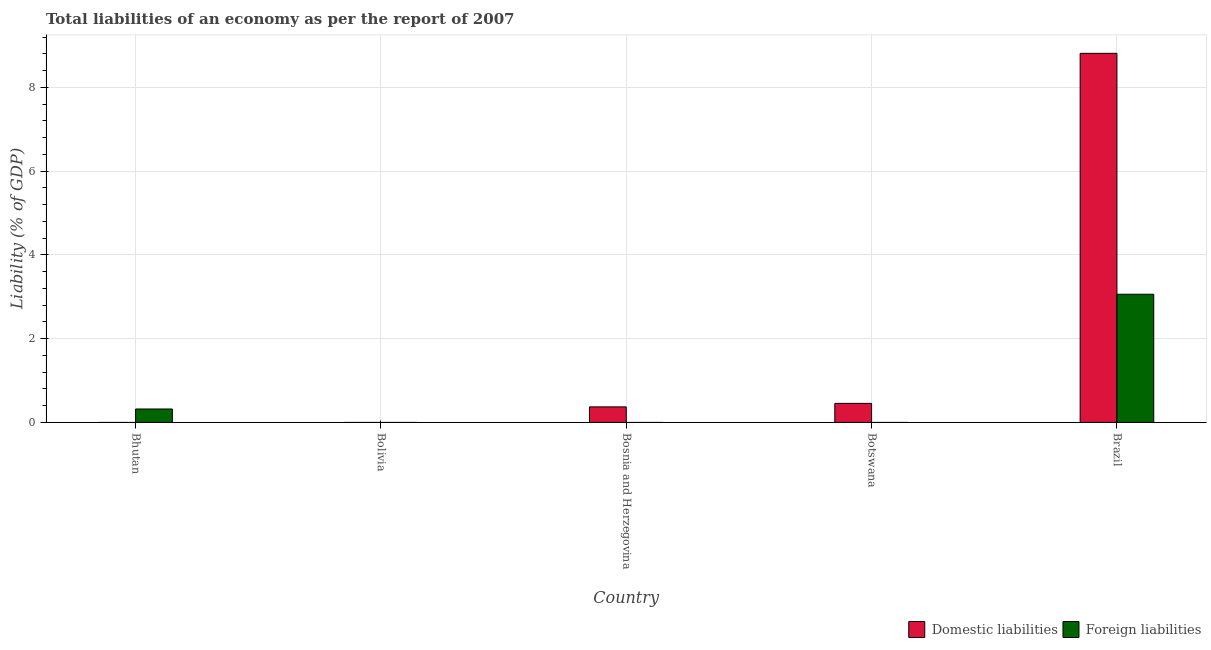Are the number of bars per tick equal to the number of legend labels?
Offer a very short reply. No. How many bars are there on the 3rd tick from the right?
Your response must be concise. 1. What is the label of the 4th group of bars from the left?
Offer a very short reply. Botswana. In how many cases, is the number of bars for a given country not equal to the number of legend labels?
Keep it short and to the point. 4. What is the incurrence of foreign liabilities in Bhutan?
Offer a terse response. 0.32. Across all countries, what is the maximum incurrence of foreign liabilities?
Provide a succinct answer. 3.06. Across all countries, what is the minimum incurrence of foreign liabilities?
Your response must be concise. 0. What is the total incurrence of foreign liabilities in the graph?
Provide a short and direct response. 3.38. What is the difference between the incurrence of domestic liabilities in Botswana and that in Brazil?
Offer a terse response. -8.36. What is the difference between the incurrence of foreign liabilities in Brazil and the incurrence of domestic liabilities in Bhutan?
Provide a short and direct response. 3.06. What is the average incurrence of domestic liabilities per country?
Give a very brief answer. 1.93. What is the difference between the incurrence of domestic liabilities and incurrence of foreign liabilities in Brazil?
Make the answer very short. 5.75. What is the ratio of the incurrence of domestic liabilities in Bosnia and Herzegovina to that in Botswana?
Keep it short and to the point. 0.82. Is the incurrence of domestic liabilities in Botswana less than that in Brazil?
Your response must be concise. Yes. What is the difference between the highest and the second highest incurrence of domestic liabilities?
Make the answer very short. 8.36. What is the difference between the highest and the lowest incurrence of domestic liabilities?
Provide a succinct answer. 8.81. How many bars are there?
Make the answer very short. 5. Are all the bars in the graph horizontal?
Keep it short and to the point. No. What is the difference between two consecutive major ticks on the Y-axis?
Offer a terse response. 2. Are the values on the major ticks of Y-axis written in scientific E-notation?
Make the answer very short. No. Does the graph contain any zero values?
Make the answer very short. Yes. Where does the legend appear in the graph?
Make the answer very short. Bottom right. How are the legend labels stacked?
Make the answer very short. Horizontal. What is the title of the graph?
Your answer should be very brief. Total liabilities of an economy as per the report of 2007. What is the label or title of the Y-axis?
Keep it short and to the point. Liability (% of GDP). What is the Liability (% of GDP) of Domestic liabilities in Bhutan?
Offer a very short reply. 0. What is the Liability (% of GDP) in Foreign liabilities in Bhutan?
Offer a very short reply. 0.32. What is the Liability (% of GDP) in Domestic liabilities in Bolivia?
Keep it short and to the point. 0. What is the Liability (% of GDP) of Foreign liabilities in Bolivia?
Your answer should be very brief. 0. What is the Liability (% of GDP) in Domestic liabilities in Bosnia and Herzegovina?
Give a very brief answer. 0.37. What is the Liability (% of GDP) in Domestic liabilities in Botswana?
Your answer should be very brief. 0.45. What is the Liability (% of GDP) in Foreign liabilities in Botswana?
Offer a very short reply. 0. What is the Liability (% of GDP) in Domestic liabilities in Brazil?
Provide a succinct answer. 8.81. What is the Liability (% of GDP) of Foreign liabilities in Brazil?
Your response must be concise. 3.06. Across all countries, what is the maximum Liability (% of GDP) in Domestic liabilities?
Keep it short and to the point. 8.81. Across all countries, what is the maximum Liability (% of GDP) of Foreign liabilities?
Keep it short and to the point. 3.06. Across all countries, what is the minimum Liability (% of GDP) of Domestic liabilities?
Offer a very short reply. 0. What is the total Liability (% of GDP) in Domestic liabilities in the graph?
Ensure brevity in your answer.  9.64. What is the total Liability (% of GDP) of Foreign liabilities in the graph?
Your answer should be very brief. 3.38. What is the difference between the Liability (% of GDP) of Foreign liabilities in Bhutan and that in Brazil?
Give a very brief answer. -2.74. What is the difference between the Liability (% of GDP) of Domestic liabilities in Bosnia and Herzegovina and that in Botswana?
Provide a short and direct response. -0.08. What is the difference between the Liability (% of GDP) of Domestic liabilities in Bosnia and Herzegovina and that in Brazil?
Your answer should be very brief. -8.44. What is the difference between the Liability (% of GDP) in Domestic liabilities in Botswana and that in Brazil?
Keep it short and to the point. -8.36. What is the difference between the Liability (% of GDP) in Domestic liabilities in Bosnia and Herzegovina and the Liability (% of GDP) in Foreign liabilities in Brazil?
Keep it short and to the point. -2.69. What is the difference between the Liability (% of GDP) of Domestic liabilities in Botswana and the Liability (% of GDP) of Foreign liabilities in Brazil?
Offer a terse response. -2.61. What is the average Liability (% of GDP) in Domestic liabilities per country?
Keep it short and to the point. 1.93. What is the average Liability (% of GDP) in Foreign liabilities per country?
Provide a succinct answer. 0.68. What is the difference between the Liability (% of GDP) of Domestic liabilities and Liability (% of GDP) of Foreign liabilities in Brazil?
Your answer should be compact. 5.75. What is the ratio of the Liability (% of GDP) of Foreign liabilities in Bhutan to that in Brazil?
Make the answer very short. 0.1. What is the ratio of the Liability (% of GDP) of Domestic liabilities in Bosnia and Herzegovina to that in Botswana?
Provide a short and direct response. 0.82. What is the ratio of the Liability (% of GDP) of Domestic liabilities in Bosnia and Herzegovina to that in Brazil?
Your answer should be compact. 0.04. What is the ratio of the Liability (% of GDP) of Domestic liabilities in Botswana to that in Brazil?
Your response must be concise. 0.05. What is the difference between the highest and the second highest Liability (% of GDP) in Domestic liabilities?
Provide a succinct answer. 8.36. What is the difference between the highest and the lowest Liability (% of GDP) in Domestic liabilities?
Your response must be concise. 8.81. What is the difference between the highest and the lowest Liability (% of GDP) in Foreign liabilities?
Provide a succinct answer. 3.06. 